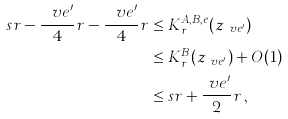<formula> <loc_0><loc_0><loc_500><loc_500>s r - \frac { \ v e ^ { \prime } } { 4 } r - \frac { \ v e ^ { \prime } } { 4 } r & \leq K ^ { A , B , e } _ { r } ( z _ { \ v e ^ { \prime } } ) \\ & \leq K ^ { B } _ { r } ( z _ { \ v e ^ { \prime } } ) + O ( 1 ) \\ & \leq s r + \frac { \ v e ^ { \prime } } { 2 } r \, ,</formula> 